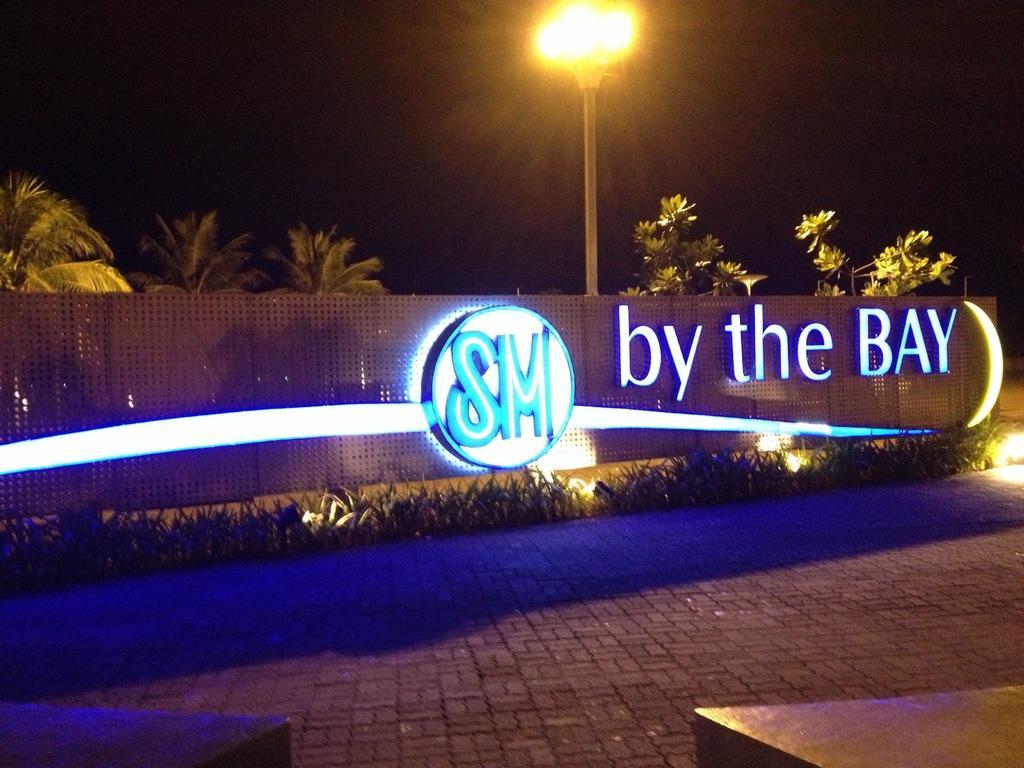Can you describe this image briefly? Here we can see a board with a name of " by the bay". In-front of this board there are plants. Backside of this board there are trees and light pole. 